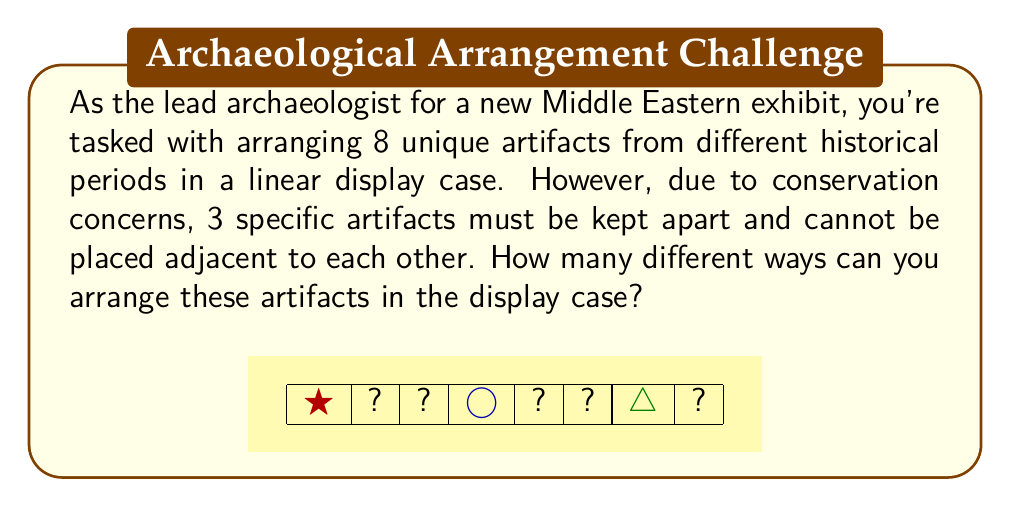Help me with this question. Let's approach this step-by-step:

1) First, we need to calculate the total number of permutations without restrictions:
   $$8! = 40,320$$

2) Now, we need to subtract the arrangements where the 3 specific artifacts are adjacent. To do this, we can:
   a) Consider these 3 artifacts as one unit
   b) Permute this unit with the other 5 artifacts
   c) Multiply by the number of ways to arrange the 3 artifacts within their unit

3) Calculating the arrangements with the 3 artifacts adjacent:
   $$6! \cdot 3! = 720 \cdot 6 = 4,320$$

4) Therefore, the number of valid arrangements is:
   $$8! - (6! \cdot 3!) = 40,320 - 4,320 = 36,000$$

5) We can verify this using the Inclusion-Exclusion Principle:
   Let $A$ be the set of arrangements where artifacts 1 and 2 are adjacent
   Let $B$ be the set of arrangements where artifacts 2 and 3 are adjacent
   Let $C$ be the set of arrangements where artifacts 1 and 3 are adjacent

   $$|A| = |B| = |C| = 7! = 5,040$$
   $$|A \cap B| = |B \cap C| = |A \cap C| = 6! = 720$$
   $$|A \cap B \cap C| = 6! = 720$$

   Valid arrangements = $8! - (|A| + |B| + |C| - |A \cap B| - |B \cap C| - |A \cap C| + |A \cap B \cap C|)$
   $$= 40,320 - (5,040 + 5,040 + 5,040 - 720 - 720 - 720 + 720) = 36,000$$

This confirms our initial calculation.
Answer: 36,000 